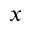Convert formula to latex. <formula><loc_0><loc_0><loc_500><loc_500>x</formula> 